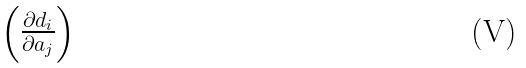Convert formula to latex. <formula><loc_0><loc_0><loc_500><loc_500>\begin{pmatrix} \frac { \partial d _ { i } } { \partial a _ { j } } \end{pmatrix}</formula> 